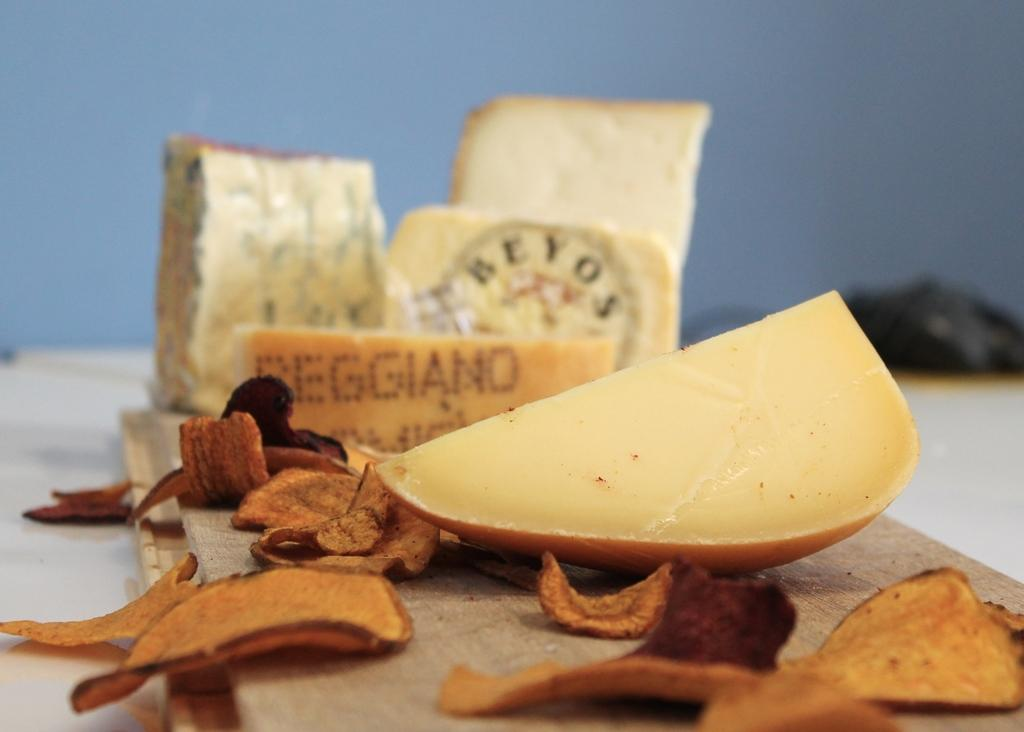What type of food can be seen in the image? There are chips and a fruit in the image. What else is present in the image besides food? There is text visible in the image, as well as pieces of bread. Can you describe the background of the image? The background of the image is blurry. What type of vessel is being used to serve the chips in the image? There is no vessel visible in the image; the chips are not being served in any container. 